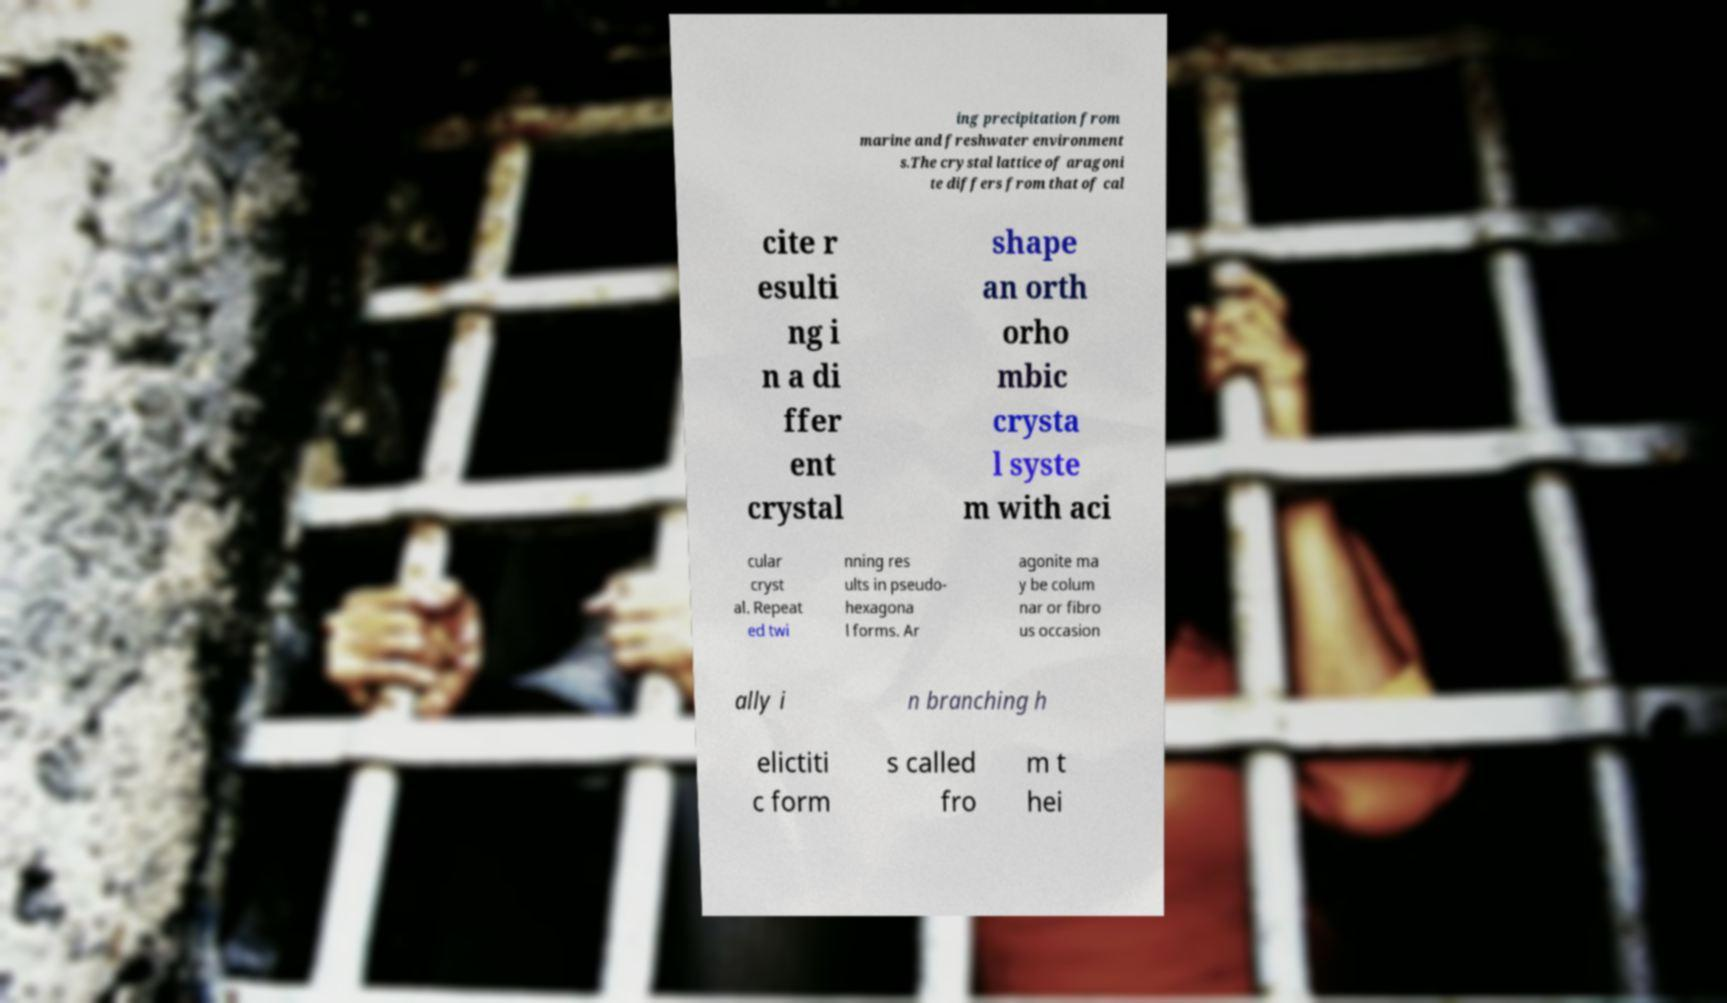Please read and relay the text visible in this image. What does it say? ing precipitation from marine and freshwater environment s.The crystal lattice of aragoni te differs from that of cal cite r esulti ng i n a di ffer ent crystal shape an orth orho mbic crysta l syste m with aci cular cryst al. Repeat ed twi nning res ults in pseudo- hexagona l forms. Ar agonite ma y be colum nar or fibro us occasion ally i n branching h elictiti c form s called fro m t hei 